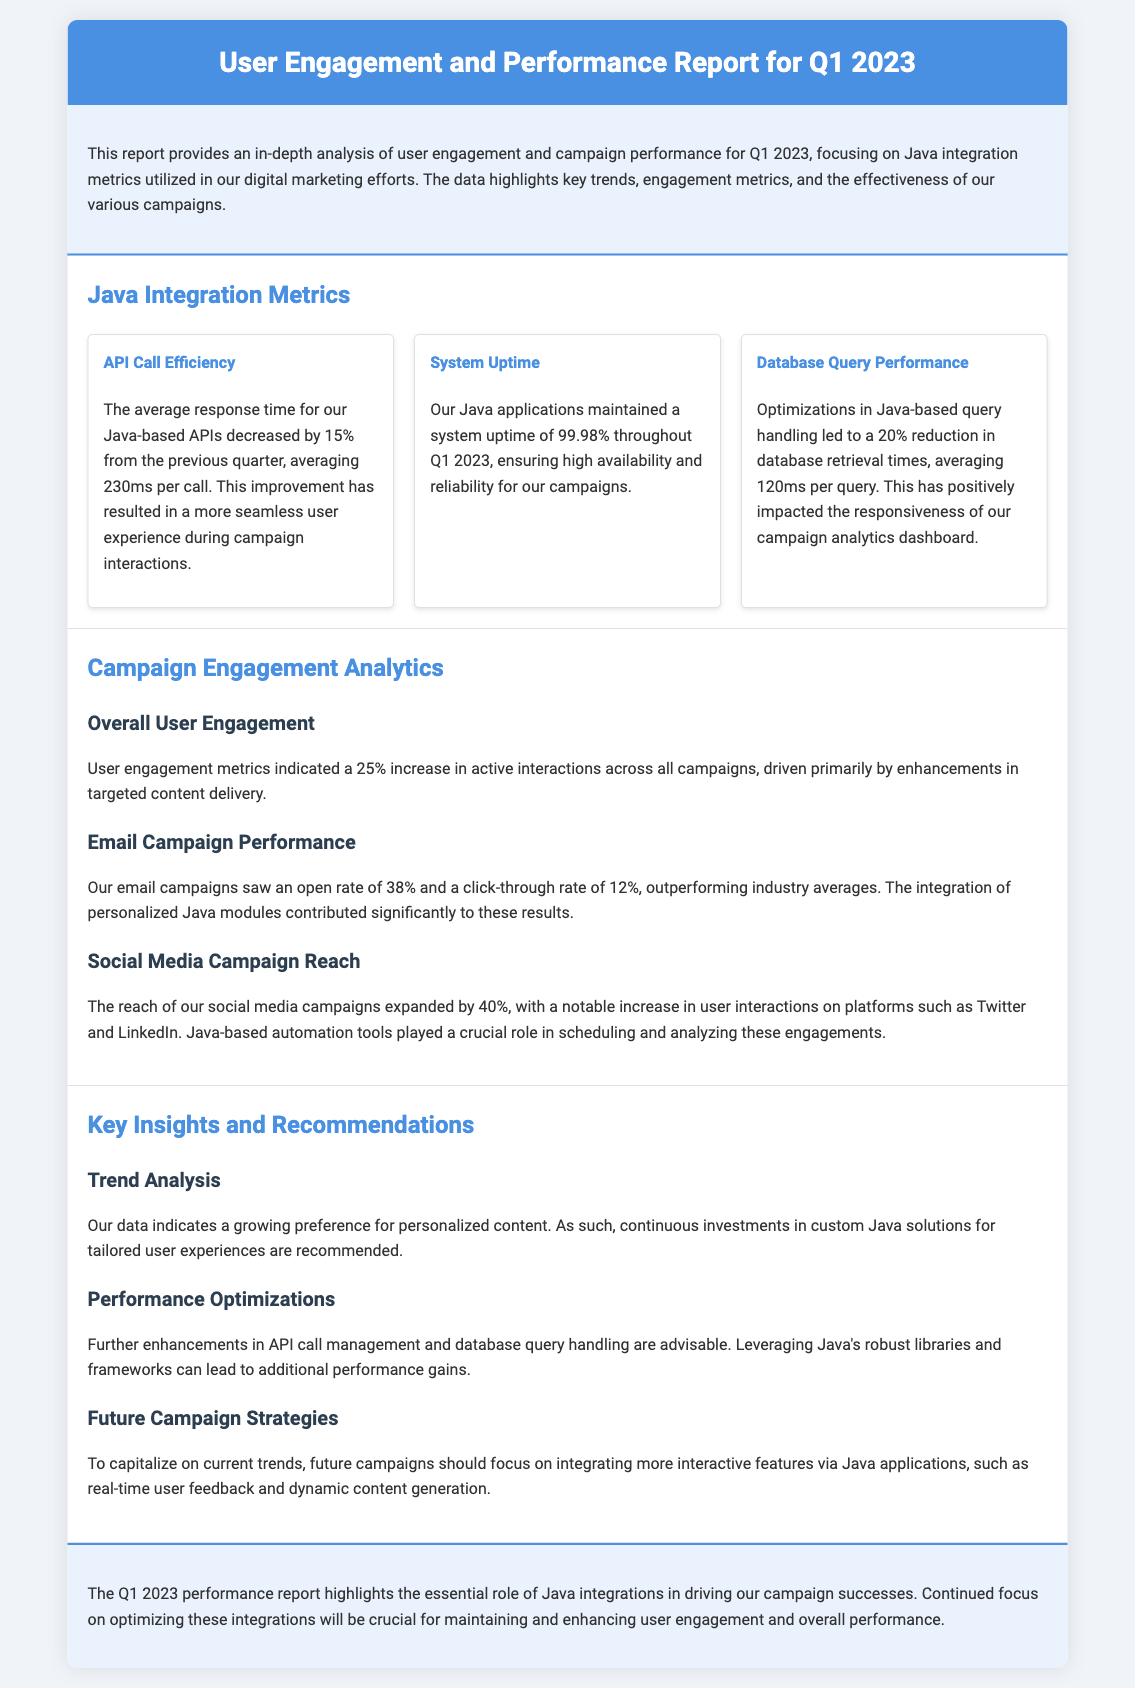What was the average response time for Java-based APIs in Q1 2023? The average response time decreased by 15% from the previous quarter, averaging 230ms per call.
Answer: 230ms What was the system uptime percentage for Java applications in Q1 2023? The report states that Java applications maintained a system uptime of 99.98%.
Answer: 99.98% What was the increase in overall user engagement in Q1 2023? User engagement metrics indicated a 25% increase in active interactions across all campaigns.
Answer: 25% What was the open rate for email campaigns? The email campaigns saw an open rate of 38%.
Answer: 38% What percentage did the social media campaign reach expand by? The reach of social media campaigns expanded by 40%.
Answer: 40% Why are further enhancements in API call management advisable? The document recommends further enhancements due to potential for additional performance gains.
Answer: Performance gains What is a suggested focus for future campaigns? Future campaigns should focus on integrating more interactive features via Java applications.
Answer: Interactive features What improvement was made in database retrieval times? Optimizations in Java-based query handling led to a 20% reduction in database retrieval times.
Answer: 20% What content delivery method is suggested for investment? Continuous investments in custom Java solutions for tailored user experiences are recommended.
Answer: Custom Java solutions 